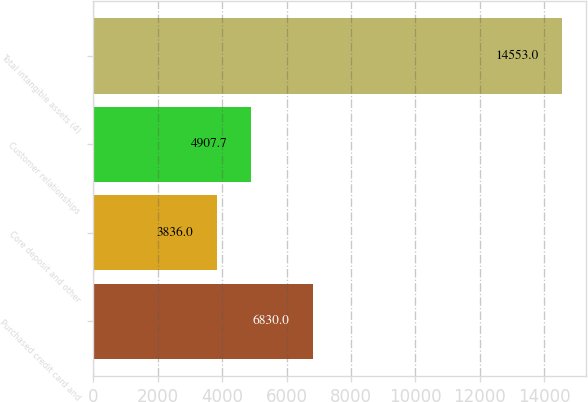<chart> <loc_0><loc_0><loc_500><loc_500><bar_chart><fcel>Purchased credit card and<fcel>Core deposit and other<fcel>Customer relationships<fcel>Total intangible assets (4)<nl><fcel>6830<fcel>3836<fcel>4907.7<fcel>14553<nl></chart> 